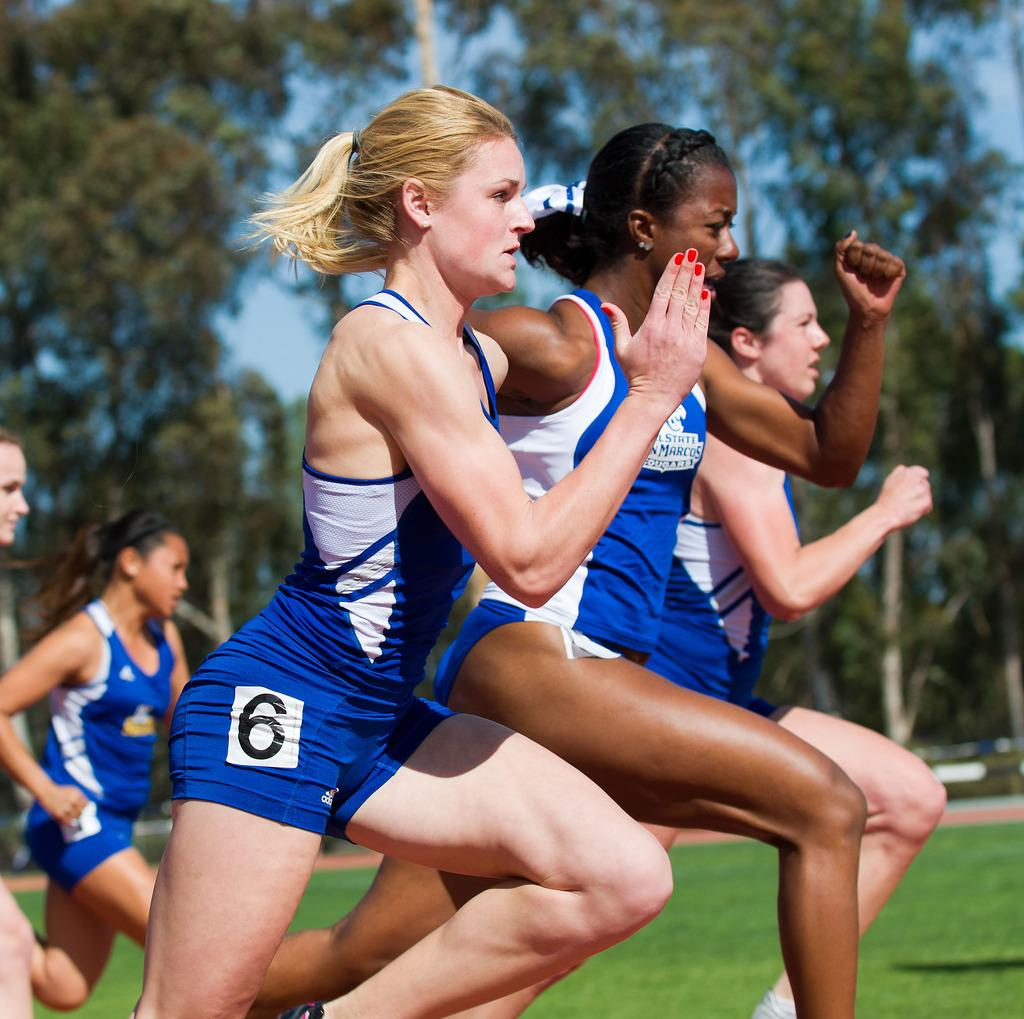Provide a one-sentence caption for the provided image. Three runners are very close in a race with number 6 on the outside. 